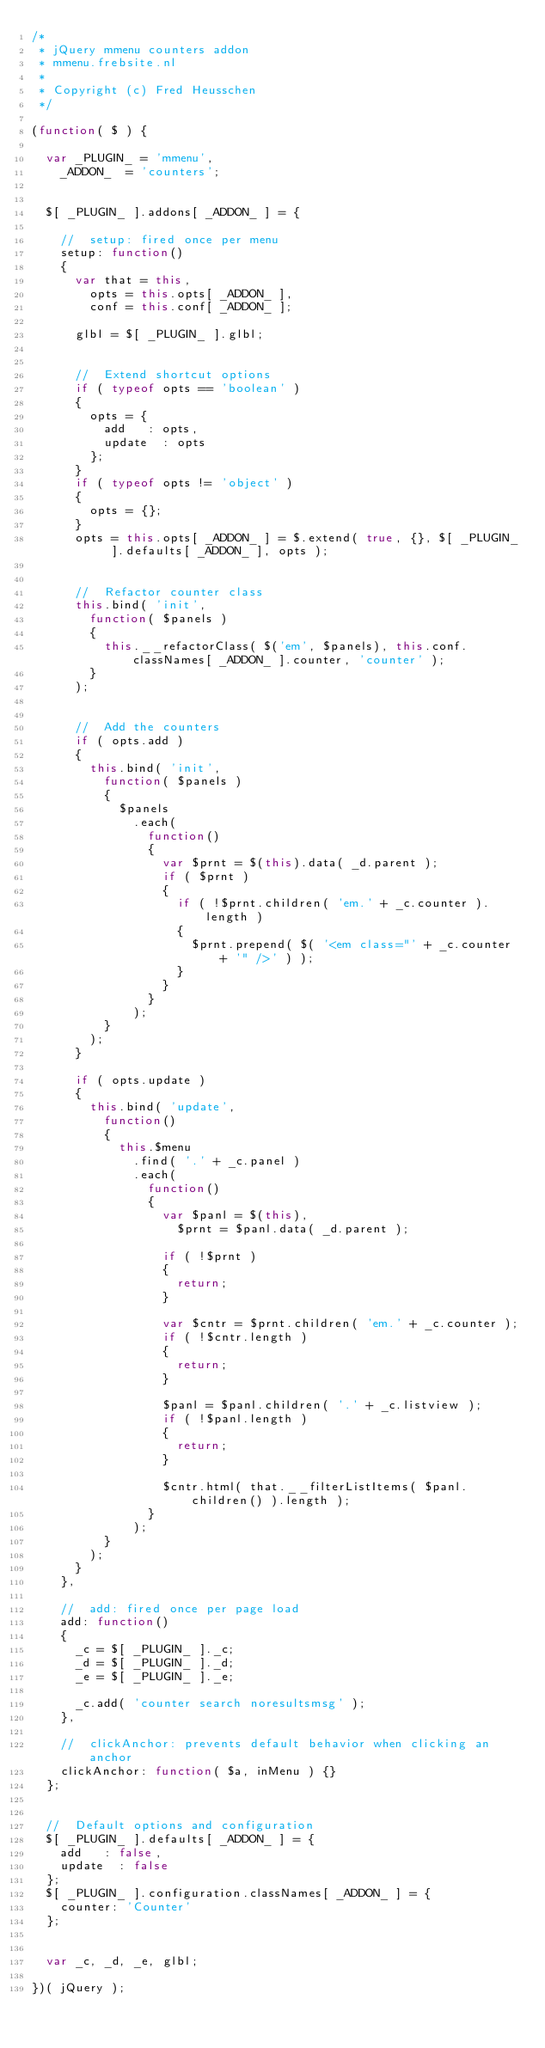Convert code to text. <code><loc_0><loc_0><loc_500><loc_500><_JavaScript_>/*	
 * jQuery mmenu counters addon
 * mmenu.frebsite.nl
 *
 * Copyright (c) Fred Heusschen
 */

(function( $ ) {

	var _PLUGIN_ = 'mmenu',
		_ADDON_  = 'counters';


	$[ _PLUGIN_ ].addons[ _ADDON_ ] = {

		//	setup: fired once per menu
		setup: function()
		{
			var that = this,
				opts = this.opts[ _ADDON_ ],
				conf = this.conf[ _ADDON_ ];

			glbl = $[ _PLUGIN_ ].glbl;


			//	Extend shortcut options
			if ( typeof opts == 'boolean' )
			{
				opts = {
					add		: opts,
					update	: opts
				};
			}
			if ( typeof opts != 'object' )
			{
				opts = {};
			}
			opts = this.opts[ _ADDON_ ] = $.extend( true, {}, $[ _PLUGIN_ ].defaults[ _ADDON_ ], opts );


			//	Refactor counter class
			this.bind( 'init',
				function( $panels )
				{
					this.__refactorClass( $('em', $panels), this.conf.classNames[ _ADDON_ ].counter, 'counter' );
				}
			);


			//	Add the counters
			if ( opts.add )
			{
				this.bind( 'init',
					function( $panels )
					{
						$panels
							.each(
								function()
								{
									var $prnt = $(this).data( _d.parent );
									if ( $prnt )
									{
										if ( !$prnt.children( 'em.' + _c.counter ).length )
										{
											$prnt.prepend( $( '<em class="' + _c.counter + '" />' ) );
										}
									}
								}
							);
					}
				);
			}

			if ( opts.update )
			{
				this.bind( 'update',
					function()
					{
						this.$menu
							.find( '.' + _c.panel )
							.each(
								function()
								{
									var $panl = $(this),
										$prnt = $panl.data( _d.parent );

									if ( !$prnt )
									{
										return;
									}

									var $cntr = $prnt.children( 'em.' + _c.counter );
									if ( !$cntr.length )
									{
										return;
									}

									$panl = $panl.children( '.' + _c.listview );
									if ( !$panl.length )
									{
										return;
									}

									$cntr.html( that.__filterListItems( $panl.children() ).length );
								}
							);
					}
				);
			}
		},

		//	add: fired once per page load
		add: function()
		{
			_c = $[ _PLUGIN_ ]._c;
			_d = $[ _PLUGIN_ ]._d;
			_e = $[ _PLUGIN_ ]._e;
	
			_c.add( 'counter search noresultsmsg' );
		},

		//	clickAnchor: prevents default behavior when clicking an anchor
		clickAnchor: function( $a, inMenu ) {}
	};


	//	Default options and configuration
	$[ _PLUGIN_ ].defaults[ _ADDON_ ] = {
		add		: false,
		update	: false
	};
	$[ _PLUGIN_ ].configuration.classNames[ _ADDON_ ] = {
		counter: 'Counter'
	};


	var _c, _d, _e, glbl;

})( jQuery );</code> 